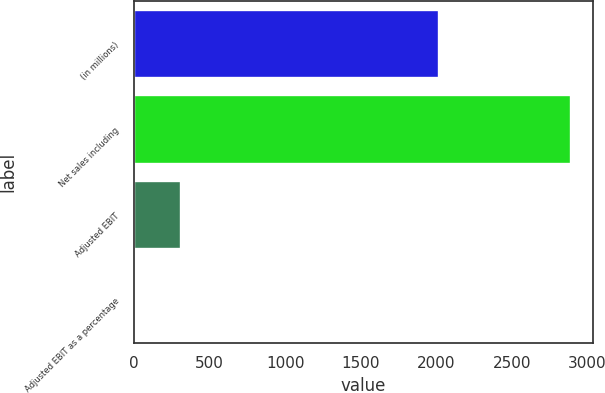<chart> <loc_0><loc_0><loc_500><loc_500><bar_chart><fcel>(in millions)<fcel>Net sales including<fcel>Adjusted EBIT<fcel>Adjusted EBIT as a percentage<nl><fcel>2019<fcel>2892.7<fcel>308.2<fcel>10.7<nl></chart> 